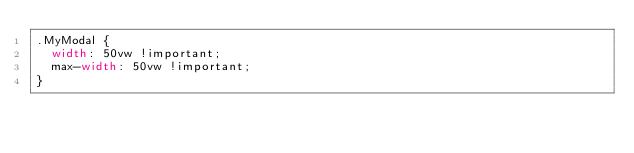<code> <loc_0><loc_0><loc_500><loc_500><_CSS_>.MyModal {
	width: 50vw !important;
	max-width: 50vw !important;
}
</code> 